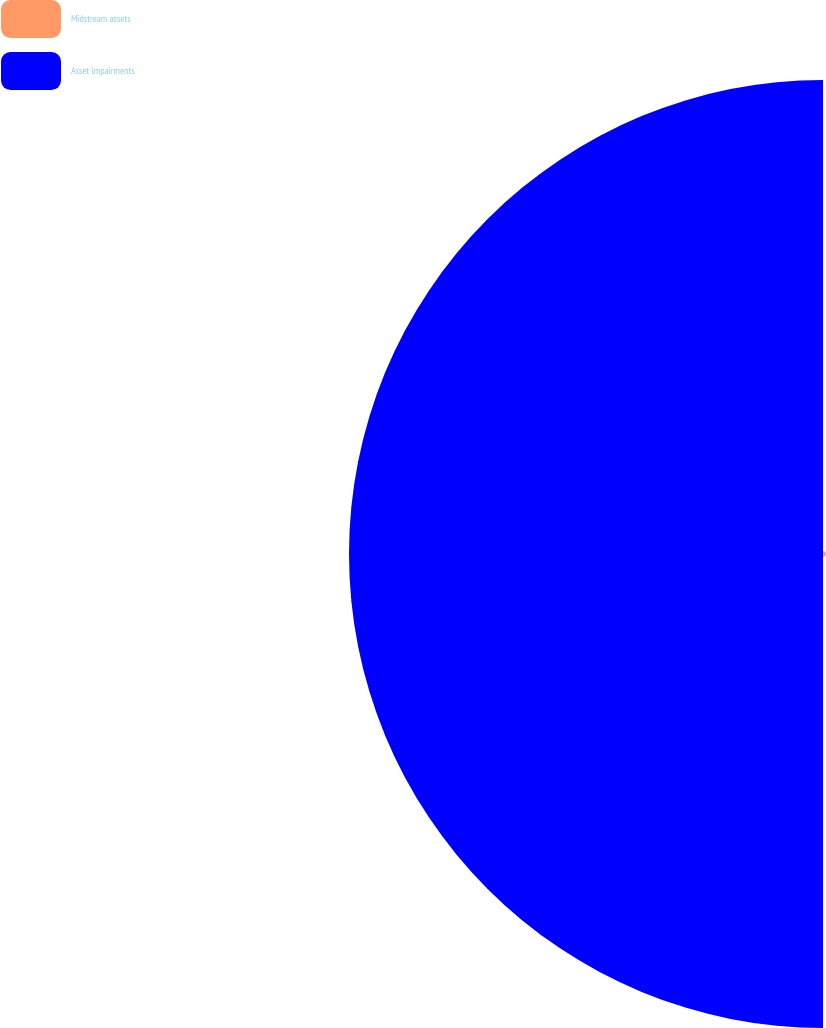Convert chart to OTSL. <chart><loc_0><loc_0><loc_500><loc_500><pie_chart><fcel>Midstream assets<fcel>Asset impairments<nl><fcel>0.61%<fcel>99.39%<nl></chart> 